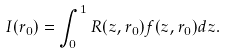<formula> <loc_0><loc_0><loc_500><loc_500>I ( r _ { 0 } ) = \int _ { 0 } ^ { 1 } R ( z , r _ { 0 } ) f ( z , r _ { 0 } ) d z .</formula> 